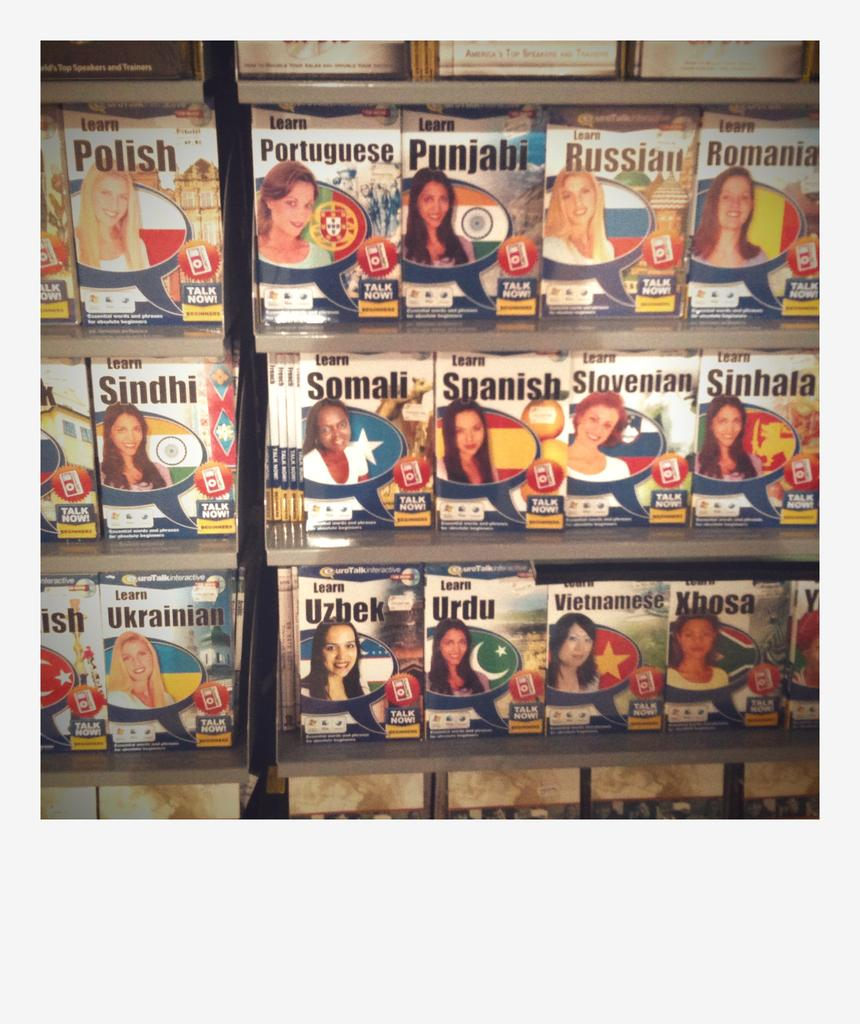Provide a one-sentence caption for the provided image. A shelf containing books on how to learn languages such as Russian or Spanish. 